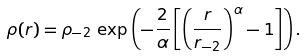<formula> <loc_0><loc_0><loc_500><loc_500>\rho ( r ) = \rho _ { - 2 } \, \exp \left ( - \frac { 2 } { \alpha } \left [ \left ( \frac { r } { r _ { - 2 } } \right ) ^ { \alpha } - 1 \right ] \right ) .</formula> 